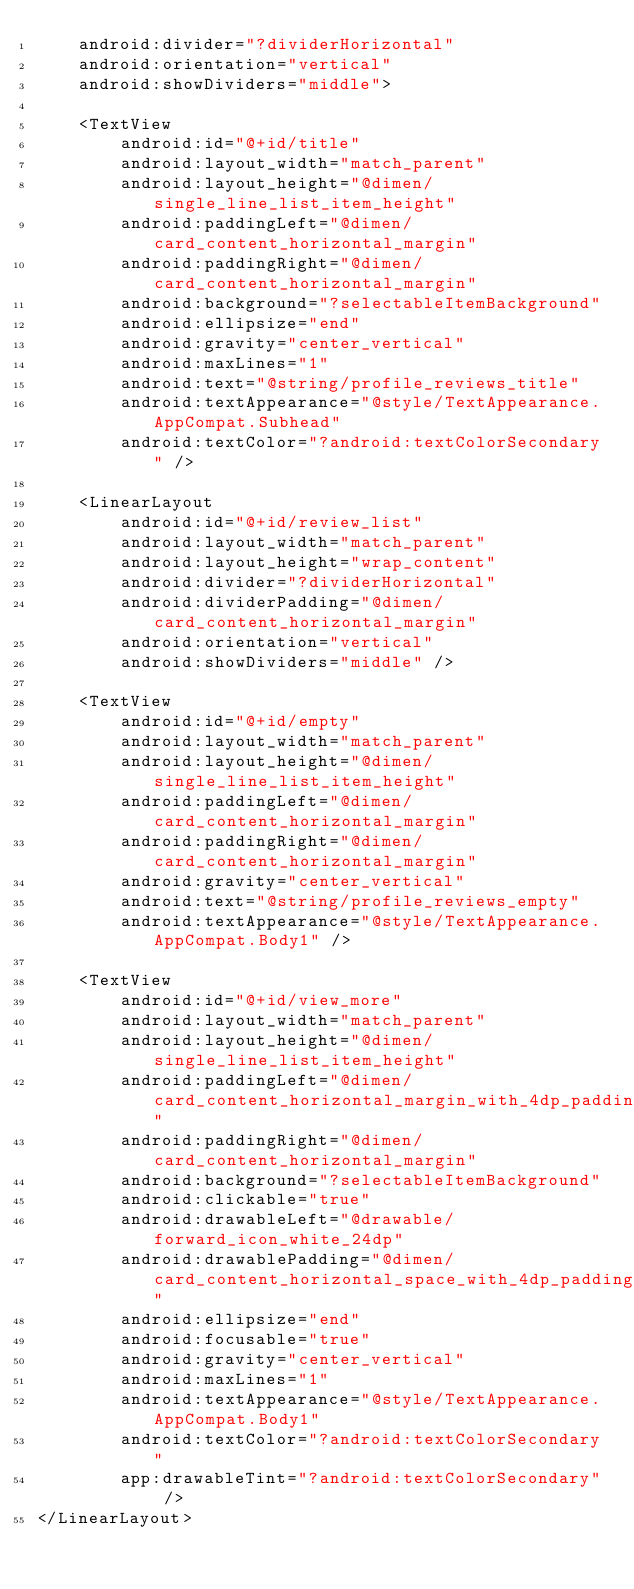Convert code to text. <code><loc_0><loc_0><loc_500><loc_500><_XML_>    android:divider="?dividerHorizontal"
    android:orientation="vertical"
    android:showDividers="middle">

    <TextView
        android:id="@+id/title"
        android:layout_width="match_parent"
        android:layout_height="@dimen/single_line_list_item_height"
        android:paddingLeft="@dimen/card_content_horizontal_margin"
        android:paddingRight="@dimen/card_content_horizontal_margin"
        android:background="?selectableItemBackground"
        android:ellipsize="end"
        android:gravity="center_vertical"
        android:maxLines="1"
        android:text="@string/profile_reviews_title"
        android:textAppearance="@style/TextAppearance.AppCompat.Subhead"
        android:textColor="?android:textColorSecondary" />

    <LinearLayout
        android:id="@+id/review_list"
        android:layout_width="match_parent"
        android:layout_height="wrap_content"
        android:divider="?dividerHorizontal"
        android:dividerPadding="@dimen/card_content_horizontal_margin"
        android:orientation="vertical"
        android:showDividers="middle" />

    <TextView
        android:id="@+id/empty"
        android:layout_width="match_parent"
        android:layout_height="@dimen/single_line_list_item_height"
        android:paddingLeft="@dimen/card_content_horizontal_margin"
        android:paddingRight="@dimen/card_content_horizontal_margin"
        android:gravity="center_vertical"
        android:text="@string/profile_reviews_empty"
        android:textAppearance="@style/TextAppearance.AppCompat.Body1" />

    <TextView
        android:id="@+id/view_more"
        android:layout_width="match_parent"
        android:layout_height="@dimen/single_line_list_item_height"
        android:paddingLeft="@dimen/card_content_horizontal_margin_with_4dp_padding"
        android:paddingRight="@dimen/card_content_horizontal_margin"
        android:background="?selectableItemBackground"
        android:clickable="true"
        android:drawableLeft="@drawable/forward_icon_white_24dp"
        android:drawablePadding="@dimen/card_content_horizontal_space_with_4dp_padding"
        android:ellipsize="end"
        android:focusable="true"
        android:gravity="center_vertical"
        android:maxLines="1"
        android:textAppearance="@style/TextAppearance.AppCompat.Body1"
        android:textColor="?android:textColorSecondary"
        app:drawableTint="?android:textColorSecondary" />
</LinearLayout>
</code> 